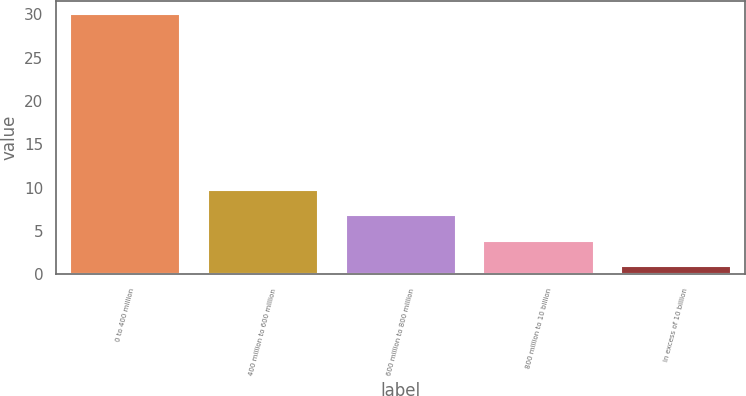<chart> <loc_0><loc_0><loc_500><loc_500><bar_chart><fcel>0 to 400 million<fcel>400 million to 600 million<fcel>600 million to 800 million<fcel>800 million to 10 billion<fcel>In excess of 10 billion<nl><fcel>30<fcel>9.7<fcel>6.8<fcel>3.9<fcel>1<nl></chart> 